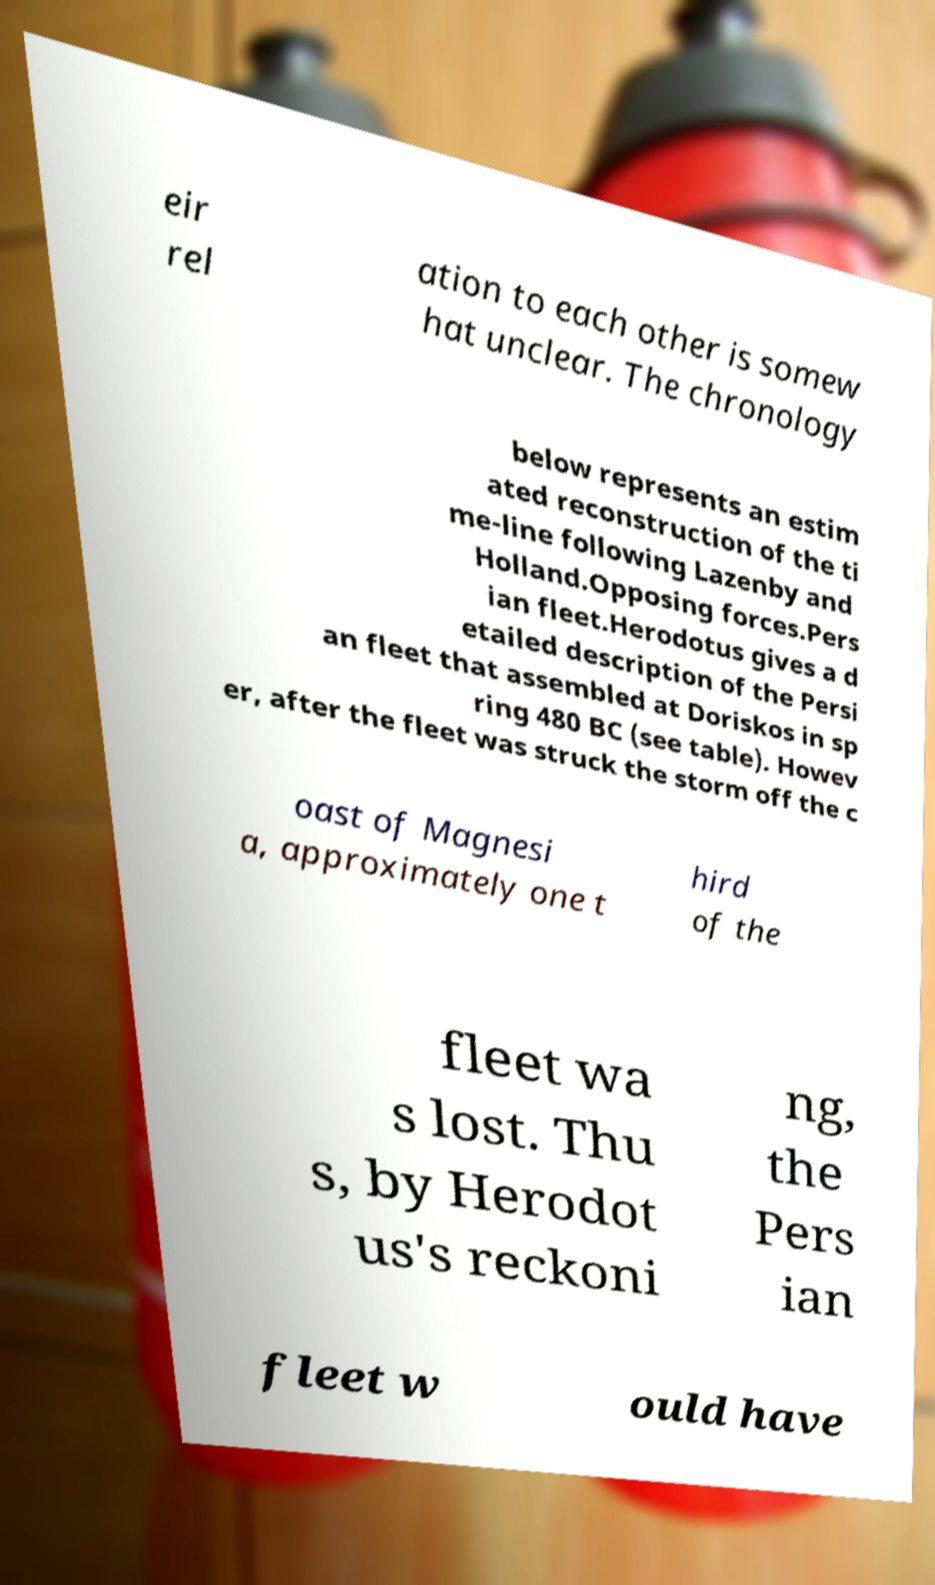Please identify and transcribe the text found in this image. eir rel ation to each other is somew hat unclear. The chronology below represents an estim ated reconstruction of the ti me-line following Lazenby and Holland.Opposing forces.Pers ian fleet.Herodotus gives a d etailed description of the Persi an fleet that assembled at Doriskos in sp ring 480 BC (see table). Howev er, after the fleet was struck the storm off the c oast of Magnesi a, approximately one t hird of the fleet wa s lost. Thu s, by Herodot us's reckoni ng, the Pers ian fleet w ould have 